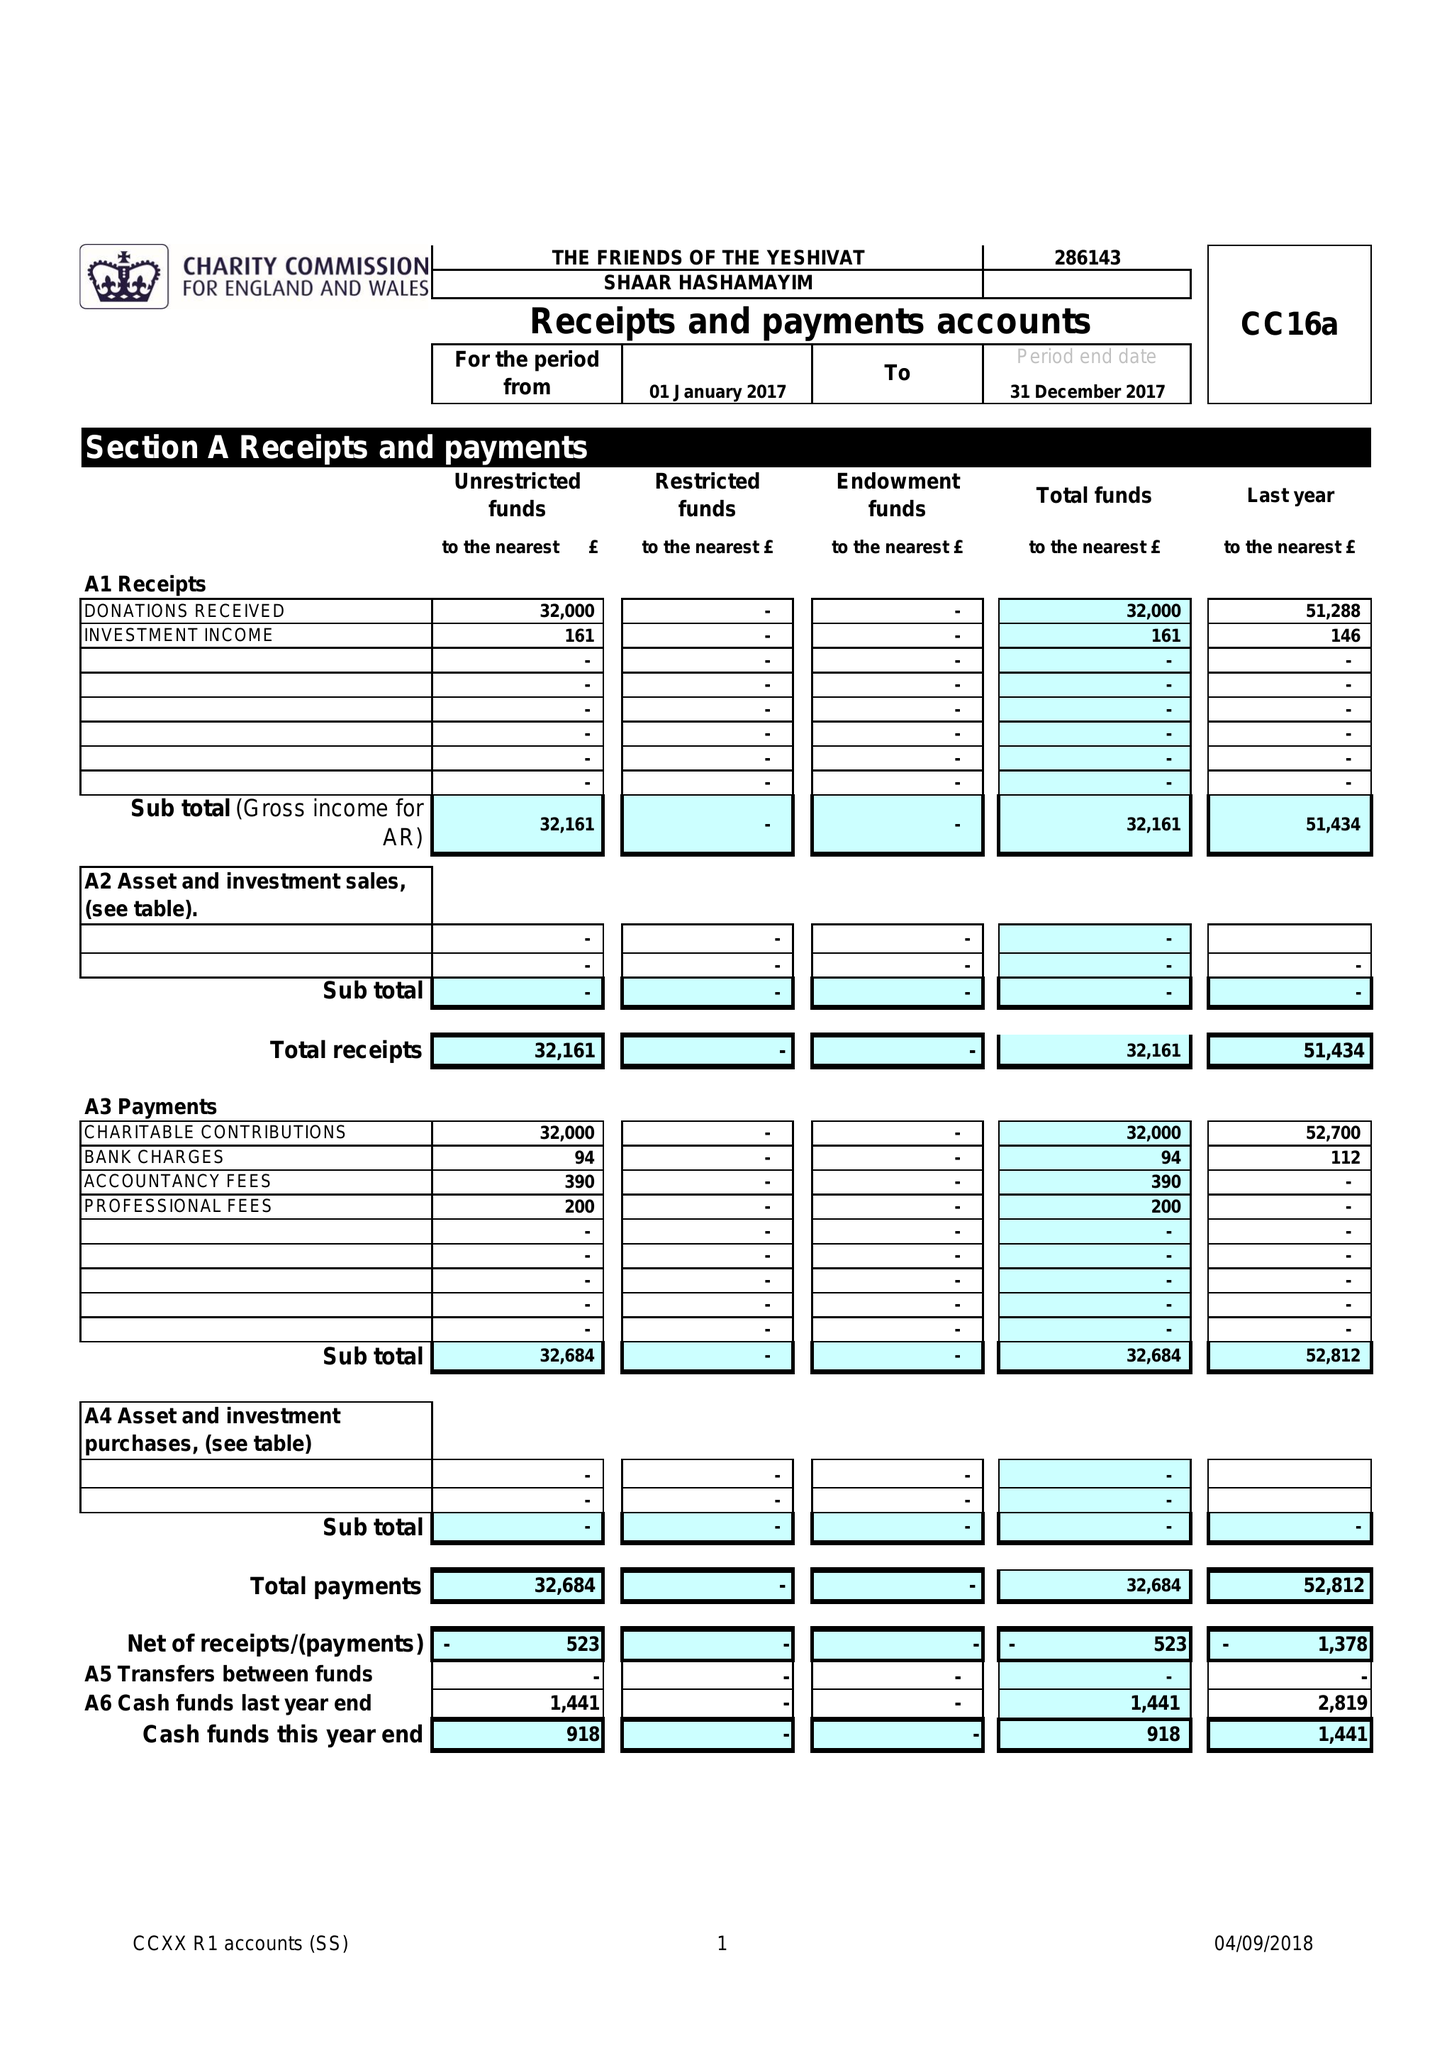What is the value for the address__post_town?
Answer the question using a single word or phrase. LONDON 